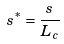Convert formula to latex. <formula><loc_0><loc_0><loc_500><loc_500>s ^ { * } = \frac { s } { L _ { c } }</formula> 